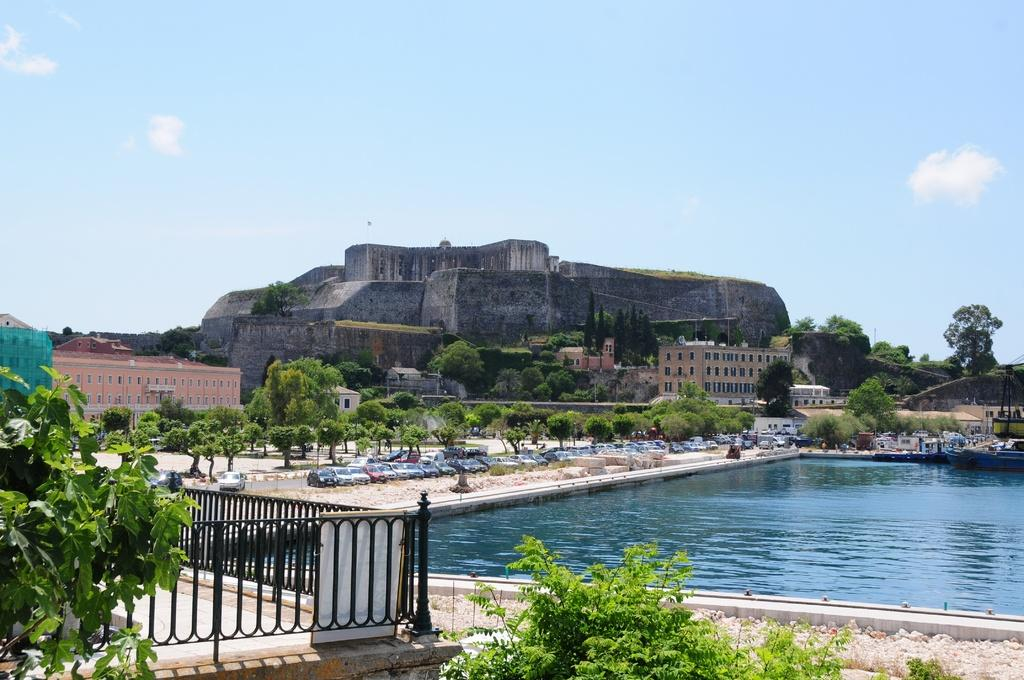What can be seen in the right corner of the image? There is water in the right corner of the image. What is located in the left corner of the image? There is a fence and plants in the left corner of the image. What is visible in the background of the image? Trees, vehicles, and buildings are visible in the background of the image. What type of stitch is used to create the circle in the image? There is no circle present in the image, so it is not possible to determine the type of stitch used. 